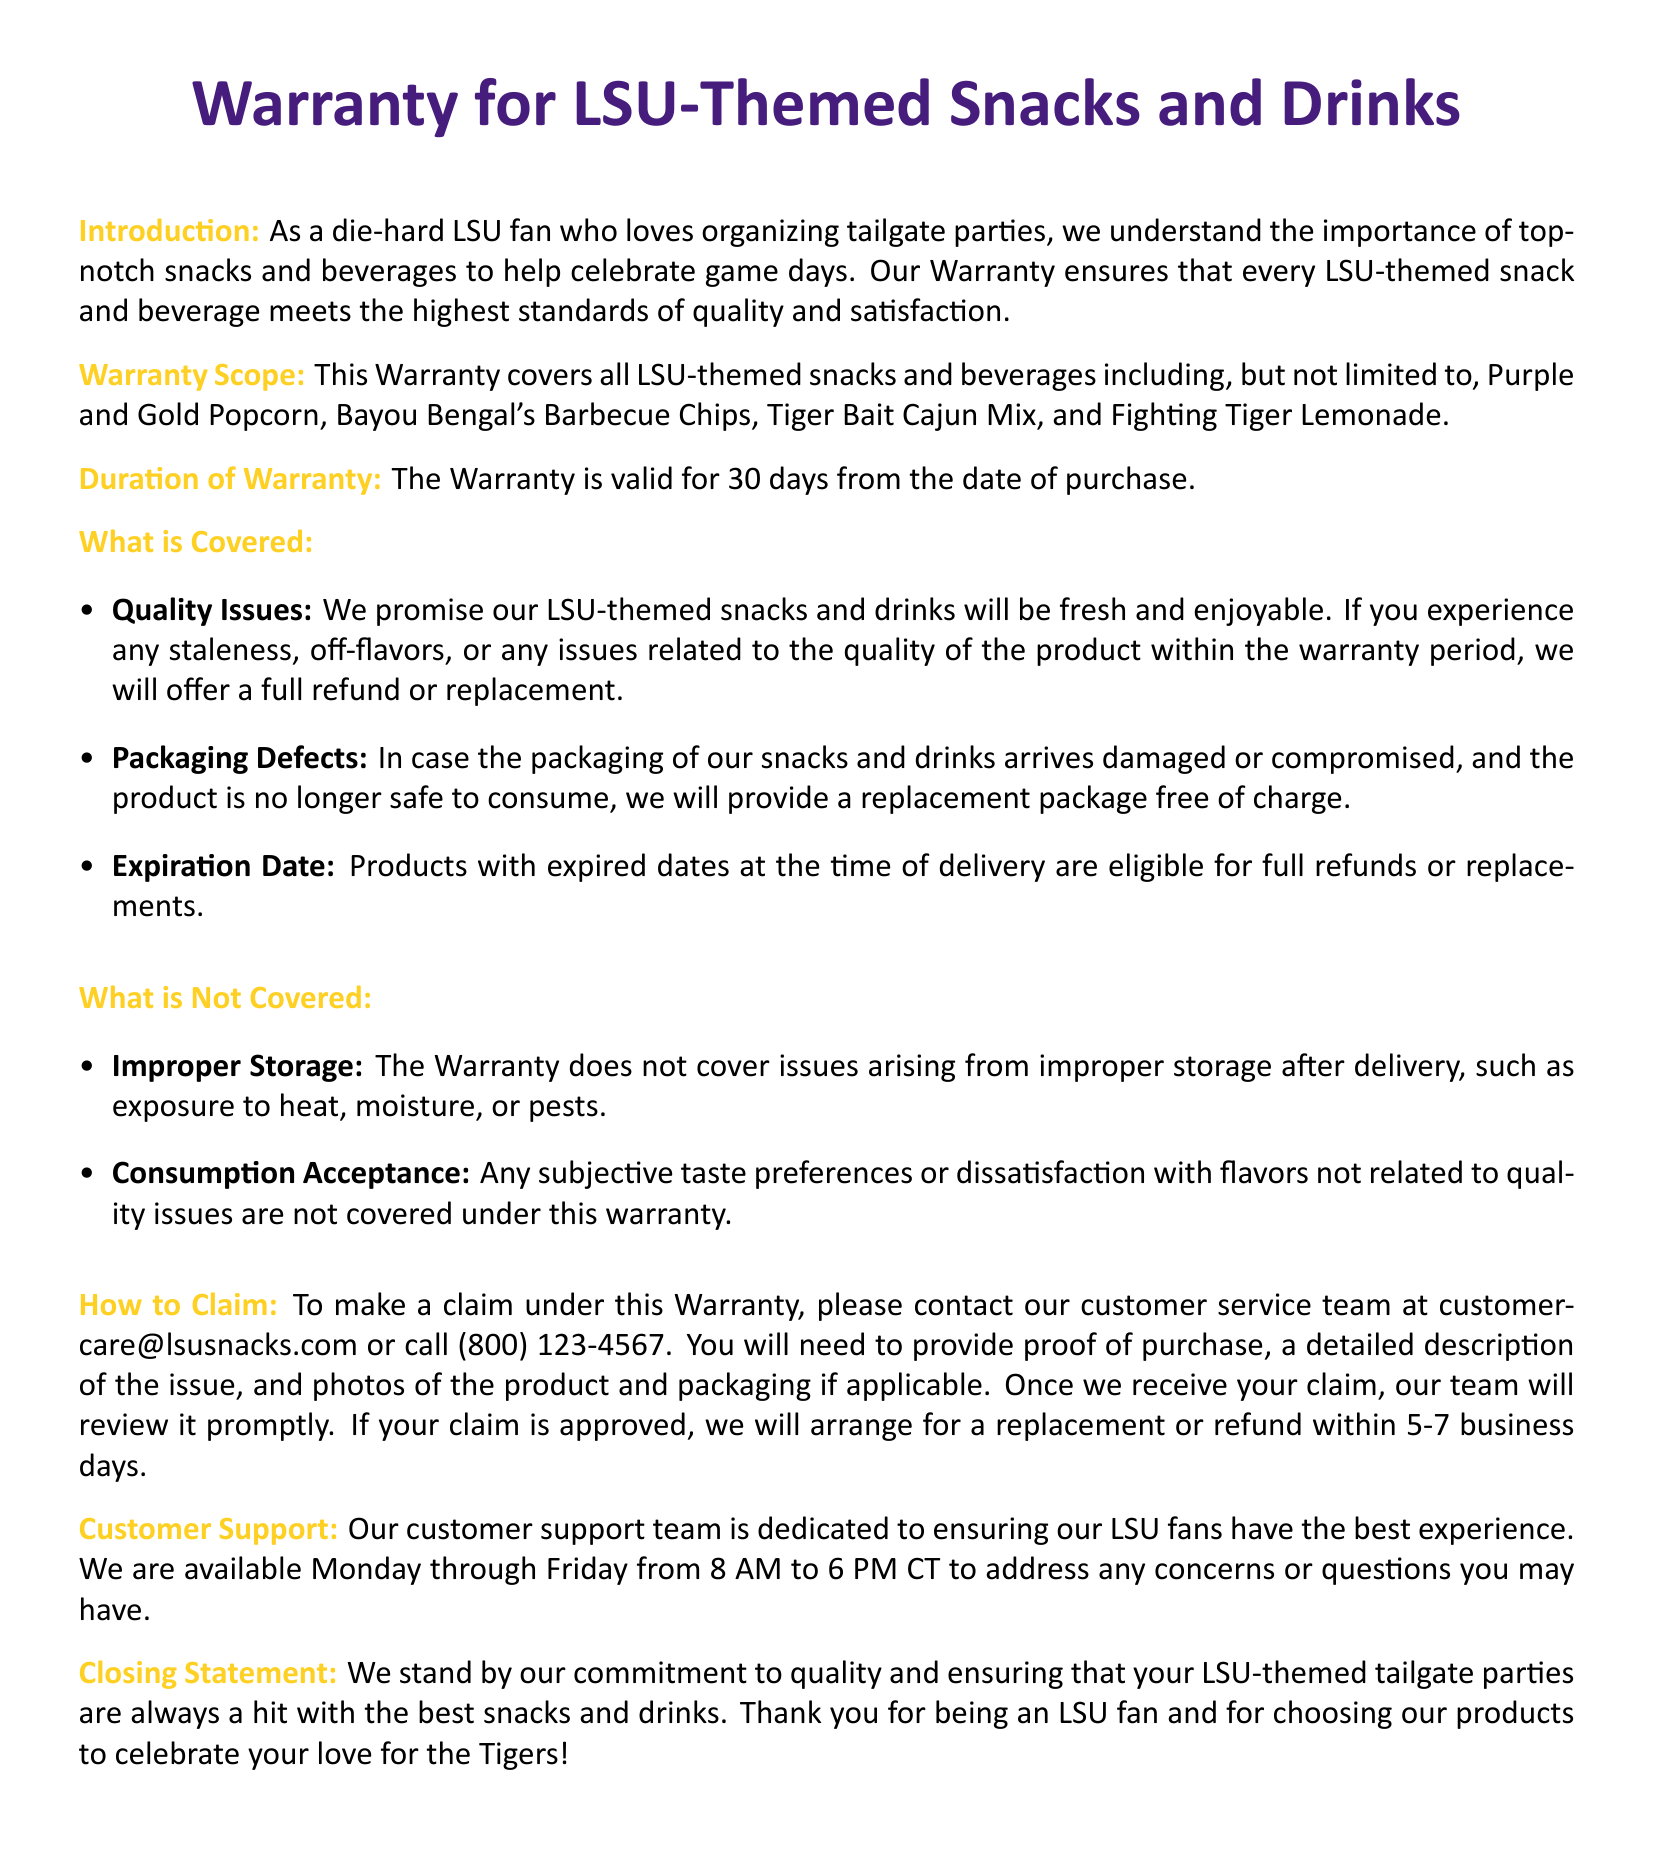What types of products are covered under the warranty? The warranty covers all LSU-themed snacks and beverages, including Purple and Gold Popcorn, Bayou Bengal's Barbecue Chips, Tiger Bait Cajun Mix, and Fighting Tiger Lemonade.
Answer: LSU-themed snacks and beverages What is the duration of the warranty? The document states that the warranty is valid for 30 days from the date of purchase.
Answer: 30 days What should you provide when making a claim? To make a claim, one must provide proof of purchase, a detailed description of the issue, and photos of the product and packaging if applicable.
Answer: Proof of purchase, description, photos What issues are not covered by the warranty? The warranty does not cover improper storage or subjective taste preferences not related to quality issues.
Answer: Improper storage, taste preferences What is the customer support email address? The customer support contact information includes an email address which is customercare@lsusnacks.com.
Answer: customercare@lsusnacks.com How long does it take to process a claim once submitted? The claim processing time stated in the document is within 5-7 business days after approval.
Answer: 5-7 business days What type of damages to packaging are covered? Damaged or compromised packaging that renders the product unsafe is covered for replacement.
Answer: Damaged packaging 